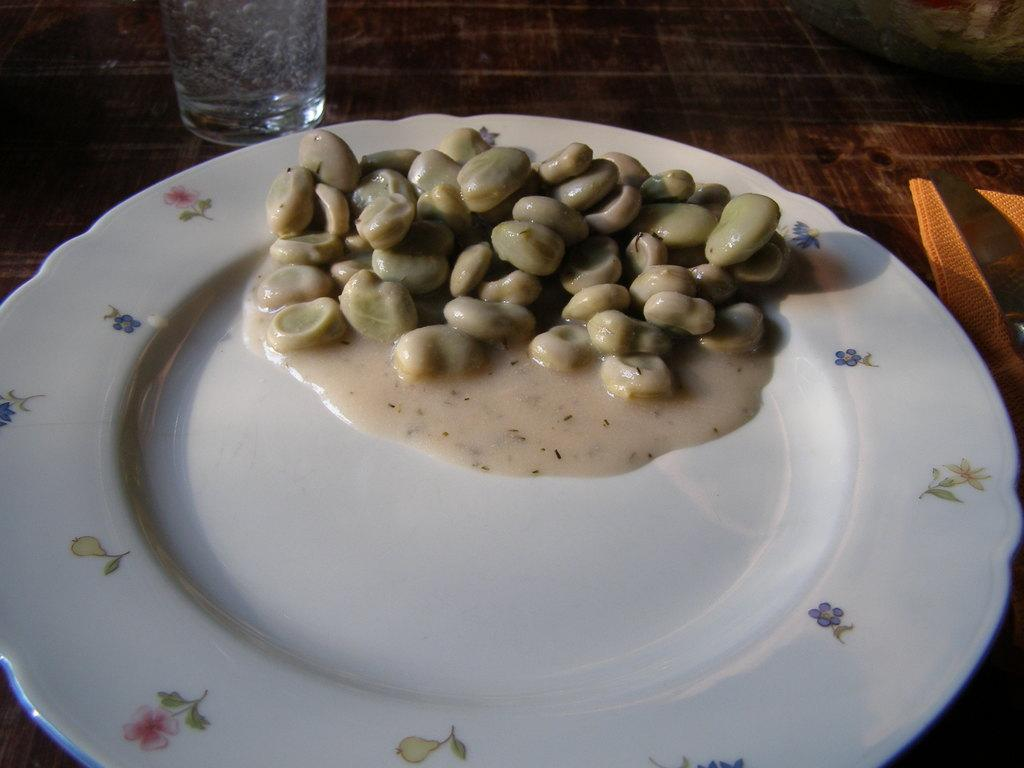What is on the white plate in the image? There is food on a white plate in the image. What type of container is visible in the image? There is a glass in the image. What is the surface that the plate and glass are placed on? The surface appears to be a table. Reasoning: Let' Let's think step by step in order to produce the conversation. We start by identifying the main subjects in the image, which are the food on the plate and the glass. Then, we describe the surface that these items are placed on, which is a table. Each question is designed to elicit a specific detail about the image that is known from the provided facts. Absurd Question/Answer: How many dolls are sitting on the table in the image? There are no dolls present in the image. What type of fruit is being used as a centerpiece on the table in the image? There is no fruit present in the image. What type of thrill can be seen in the image? There is no thrill present in the image. How many apples are being used as decoration on the table in the image? There are no apples present in the image. 